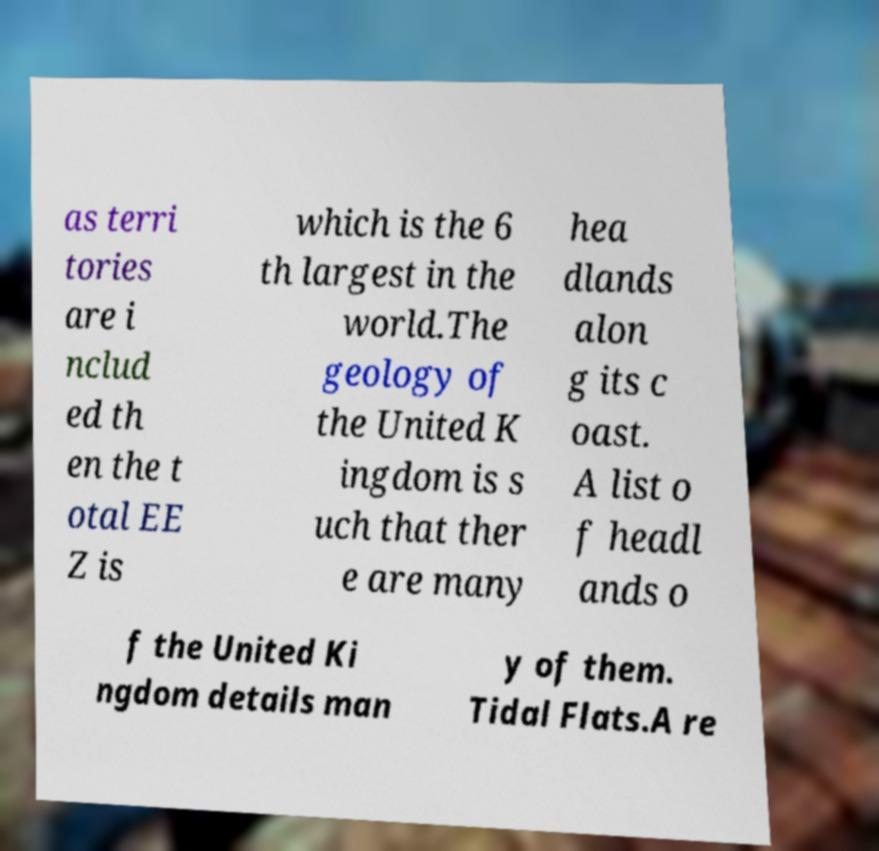Please read and relay the text visible in this image. What does it say? as terri tories are i nclud ed th en the t otal EE Z is which is the 6 th largest in the world.The geology of the United K ingdom is s uch that ther e are many hea dlands alon g its c oast. A list o f headl ands o f the United Ki ngdom details man y of them. Tidal Flats.A re 